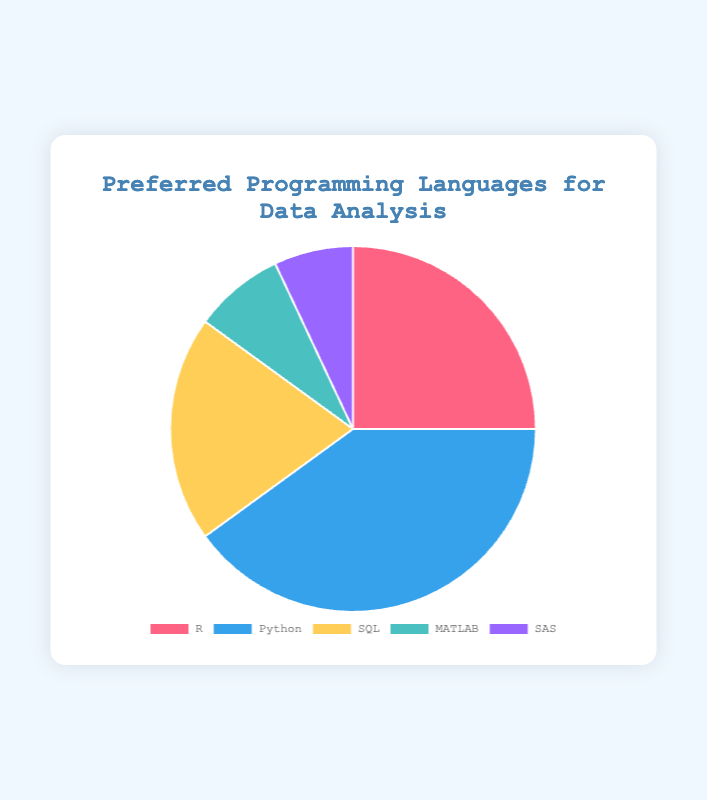Which language has the highest popularity percentage? The data shows the popularity percentages for different programming languages. Python has the highest percentage at 40%.
Answer: Python Which language is the least popular? The data shows the popularity percentages for different programming languages. SAS has the lowest percentage at 7%.
Answer: SAS What is the total popularity percentage for MATLAB and SAS combined? MATLAB has a popularity of 8% and SAS has 7%. Adding these gives 8% + 7% = 15%.
Answer: 15% How much more popular is Python than R? Python has a popularity of 40% and R has 25%. Subtracting these gives 40% - 25% = 15%.
Answer: 15% What is the combined popularity percentage of the top two programming languages? Python is 40% and R is 25%. Adding these gives 40% + 25% = 65%.
Answer: 65% How does the popularity of SQL compare to that of MATLAB? SQL has a popularity of 20% while MATLAB has 8%. Since 20% > 8%, SQL is more popular.
Answer: SQL is more popular Which programming language has a popularity percentage between MATLAB and SAS? Sorting the percentages in ascending order: SAS (7%), MATLAB (8%). No language has a popularity percentage between these two.
Answer: None If MATLAB's popularity increased by 5 percentage points, what would its new percentage be? MATLAB currently has 8%. Adding 5% gives 8% + 5% = 13%.
Answer: 13% What is the difference in popularity percentage between the most popular and least popular languages? Python is the most popular at 40% and SAS is the least popular at 7%. The difference is 40% - 7% = 33%.
Answer: 33% 